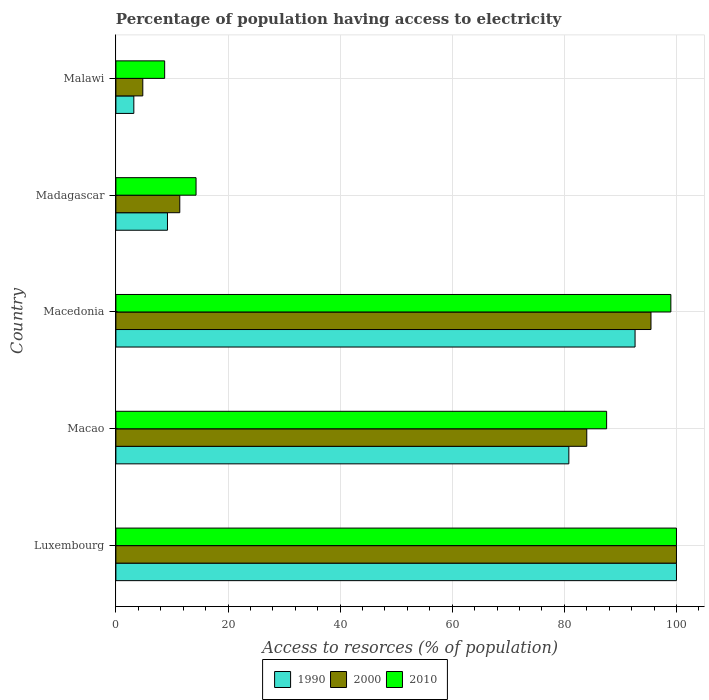How many different coloured bars are there?
Provide a short and direct response. 3. How many groups of bars are there?
Keep it short and to the point. 5. Are the number of bars per tick equal to the number of legend labels?
Keep it short and to the point. Yes. Are the number of bars on each tick of the Y-axis equal?
Your answer should be compact. Yes. How many bars are there on the 4th tick from the top?
Offer a terse response. 3. How many bars are there on the 3rd tick from the bottom?
Your answer should be compact. 3. What is the label of the 3rd group of bars from the top?
Ensure brevity in your answer.  Macedonia. In how many cases, is the number of bars for a given country not equal to the number of legend labels?
Your answer should be compact. 0. In which country was the percentage of population having access to electricity in 1990 maximum?
Keep it short and to the point. Luxembourg. In which country was the percentage of population having access to electricity in 2000 minimum?
Provide a short and direct response. Malawi. What is the total percentage of population having access to electricity in 2000 in the graph?
Offer a very short reply. 295.65. What is the difference between the percentage of population having access to electricity in 2010 in Macao and that in Macedonia?
Your answer should be compact. -11.46. What is the difference between the percentage of population having access to electricity in 2010 in Macao and the percentage of population having access to electricity in 1990 in Malawi?
Your response must be concise. 84.34. What is the average percentage of population having access to electricity in 2000 per country?
Make the answer very short. 59.13. What is the difference between the percentage of population having access to electricity in 2000 and percentage of population having access to electricity in 1990 in Malawi?
Your response must be concise. 1.6. In how many countries, is the percentage of population having access to electricity in 1990 greater than 80 %?
Your answer should be very brief. 3. What is the ratio of the percentage of population having access to electricity in 2010 in Luxembourg to that in Madagascar?
Offer a very short reply. 6.99. Is the percentage of population having access to electricity in 2000 in Macedonia less than that in Malawi?
Offer a terse response. No. Is the difference between the percentage of population having access to electricity in 2000 in Macao and Macedonia greater than the difference between the percentage of population having access to electricity in 1990 in Macao and Macedonia?
Give a very brief answer. Yes. What is the difference between the highest and the second highest percentage of population having access to electricity in 1990?
Provide a short and direct response. 7.38. What is the difference between the highest and the lowest percentage of population having access to electricity in 1990?
Give a very brief answer. 96.8. In how many countries, is the percentage of population having access to electricity in 2000 greater than the average percentage of population having access to electricity in 2000 taken over all countries?
Your response must be concise. 3. What does the 3rd bar from the bottom in Macedonia represents?
Keep it short and to the point. 2010. Is it the case that in every country, the sum of the percentage of population having access to electricity in 2010 and percentage of population having access to electricity in 2000 is greater than the percentage of population having access to electricity in 1990?
Make the answer very short. Yes. How many bars are there?
Make the answer very short. 15. Are all the bars in the graph horizontal?
Your answer should be very brief. Yes. How many countries are there in the graph?
Offer a terse response. 5. What is the difference between two consecutive major ticks on the X-axis?
Make the answer very short. 20. Does the graph contain any zero values?
Give a very brief answer. No. Does the graph contain grids?
Provide a short and direct response. Yes. Where does the legend appear in the graph?
Your answer should be compact. Bottom center. How many legend labels are there?
Keep it short and to the point. 3. How are the legend labels stacked?
Your answer should be compact. Horizontal. What is the title of the graph?
Offer a terse response. Percentage of population having access to electricity. Does "1964" appear as one of the legend labels in the graph?
Provide a short and direct response. No. What is the label or title of the X-axis?
Provide a short and direct response. Access to resorces (% of population). What is the Access to resorces (% of population) of 2000 in Luxembourg?
Offer a terse response. 100. What is the Access to resorces (% of population) of 1990 in Macao?
Your answer should be very brief. 80.8. What is the Access to resorces (% of population) in 2010 in Macao?
Offer a very short reply. 87.54. What is the Access to resorces (% of population) in 1990 in Macedonia?
Give a very brief answer. 92.62. What is the Access to resorces (% of population) in 2000 in Macedonia?
Offer a terse response. 95.46. What is the Access to resorces (% of population) of 1990 in Madagascar?
Your answer should be very brief. 9.2. What is the Access to resorces (% of population) in 2000 in Madagascar?
Give a very brief answer. 11.4. Across all countries, what is the maximum Access to resorces (% of population) in 1990?
Provide a succinct answer. 100. Across all countries, what is the maximum Access to resorces (% of population) in 2010?
Your answer should be very brief. 100. Across all countries, what is the minimum Access to resorces (% of population) in 2010?
Your answer should be compact. 8.7. What is the total Access to resorces (% of population) of 1990 in the graph?
Offer a very short reply. 285.82. What is the total Access to resorces (% of population) of 2000 in the graph?
Provide a short and direct response. 295.65. What is the total Access to resorces (% of population) in 2010 in the graph?
Give a very brief answer. 309.54. What is the difference between the Access to resorces (% of population) in 1990 in Luxembourg and that in Macao?
Make the answer very short. 19.2. What is the difference between the Access to resorces (% of population) of 2000 in Luxembourg and that in Macao?
Offer a very short reply. 16. What is the difference between the Access to resorces (% of population) in 2010 in Luxembourg and that in Macao?
Offer a very short reply. 12.46. What is the difference between the Access to resorces (% of population) of 1990 in Luxembourg and that in Macedonia?
Offer a terse response. 7.38. What is the difference between the Access to resorces (% of population) of 2000 in Luxembourg and that in Macedonia?
Your answer should be very brief. 4.54. What is the difference between the Access to resorces (% of population) in 1990 in Luxembourg and that in Madagascar?
Your response must be concise. 90.8. What is the difference between the Access to resorces (% of population) in 2000 in Luxembourg and that in Madagascar?
Provide a succinct answer. 88.6. What is the difference between the Access to resorces (% of population) in 2010 in Luxembourg and that in Madagascar?
Provide a succinct answer. 85.7. What is the difference between the Access to resorces (% of population) of 1990 in Luxembourg and that in Malawi?
Offer a terse response. 96.8. What is the difference between the Access to resorces (% of population) of 2000 in Luxembourg and that in Malawi?
Keep it short and to the point. 95.2. What is the difference between the Access to resorces (% of population) of 2010 in Luxembourg and that in Malawi?
Ensure brevity in your answer.  91.3. What is the difference between the Access to resorces (% of population) in 1990 in Macao and that in Macedonia?
Provide a short and direct response. -11.81. What is the difference between the Access to resorces (% of population) in 2000 in Macao and that in Macedonia?
Ensure brevity in your answer.  -11.46. What is the difference between the Access to resorces (% of population) in 2010 in Macao and that in Macedonia?
Make the answer very short. -11.46. What is the difference between the Access to resorces (% of population) in 1990 in Macao and that in Madagascar?
Provide a short and direct response. 71.6. What is the difference between the Access to resorces (% of population) in 2000 in Macao and that in Madagascar?
Keep it short and to the point. 72.6. What is the difference between the Access to resorces (% of population) in 2010 in Macao and that in Madagascar?
Ensure brevity in your answer.  73.24. What is the difference between the Access to resorces (% of population) in 1990 in Macao and that in Malawi?
Your response must be concise. 77.6. What is the difference between the Access to resorces (% of population) of 2000 in Macao and that in Malawi?
Keep it short and to the point. 79.2. What is the difference between the Access to resorces (% of population) of 2010 in Macao and that in Malawi?
Your answer should be compact. 78.84. What is the difference between the Access to resorces (% of population) of 1990 in Macedonia and that in Madagascar?
Ensure brevity in your answer.  83.42. What is the difference between the Access to resorces (% of population) in 2000 in Macedonia and that in Madagascar?
Your answer should be compact. 84.06. What is the difference between the Access to resorces (% of population) in 2010 in Macedonia and that in Madagascar?
Offer a terse response. 84.7. What is the difference between the Access to resorces (% of population) in 1990 in Macedonia and that in Malawi?
Provide a succinct answer. 89.42. What is the difference between the Access to resorces (% of population) in 2000 in Macedonia and that in Malawi?
Ensure brevity in your answer.  90.66. What is the difference between the Access to resorces (% of population) in 2010 in Macedonia and that in Malawi?
Make the answer very short. 90.3. What is the difference between the Access to resorces (% of population) in 2000 in Madagascar and that in Malawi?
Provide a succinct answer. 6.6. What is the difference between the Access to resorces (% of population) of 1990 in Luxembourg and the Access to resorces (% of population) of 2010 in Macao?
Your answer should be compact. 12.46. What is the difference between the Access to resorces (% of population) of 2000 in Luxembourg and the Access to resorces (% of population) of 2010 in Macao?
Your answer should be very brief. 12.46. What is the difference between the Access to resorces (% of population) in 1990 in Luxembourg and the Access to resorces (% of population) in 2000 in Macedonia?
Make the answer very short. 4.54. What is the difference between the Access to resorces (% of population) of 1990 in Luxembourg and the Access to resorces (% of population) of 2010 in Macedonia?
Your response must be concise. 1. What is the difference between the Access to resorces (% of population) in 1990 in Luxembourg and the Access to resorces (% of population) in 2000 in Madagascar?
Give a very brief answer. 88.6. What is the difference between the Access to resorces (% of population) in 1990 in Luxembourg and the Access to resorces (% of population) in 2010 in Madagascar?
Offer a very short reply. 85.7. What is the difference between the Access to resorces (% of population) of 2000 in Luxembourg and the Access to resorces (% of population) of 2010 in Madagascar?
Make the answer very short. 85.7. What is the difference between the Access to resorces (% of population) in 1990 in Luxembourg and the Access to resorces (% of population) in 2000 in Malawi?
Your answer should be compact. 95.2. What is the difference between the Access to resorces (% of population) of 1990 in Luxembourg and the Access to resorces (% of population) of 2010 in Malawi?
Provide a succinct answer. 91.3. What is the difference between the Access to resorces (% of population) in 2000 in Luxembourg and the Access to resorces (% of population) in 2010 in Malawi?
Provide a short and direct response. 91.3. What is the difference between the Access to resorces (% of population) in 1990 in Macao and the Access to resorces (% of population) in 2000 in Macedonia?
Offer a terse response. -14.65. What is the difference between the Access to resorces (% of population) in 1990 in Macao and the Access to resorces (% of population) in 2010 in Macedonia?
Give a very brief answer. -18.2. What is the difference between the Access to resorces (% of population) of 2000 in Macao and the Access to resorces (% of population) of 2010 in Macedonia?
Make the answer very short. -15. What is the difference between the Access to resorces (% of population) of 1990 in Macao and the Access to resorces (% of population) of 2000 in Madagascar?
Make the answer very short. 69.4. What is the difference between the Access to resorces (% of population) of 1990 in Macao and the Access to resorces (% of population) of 2010 in Madagascar?
Offer a very short reply. 66.5. What is the difference between the Access to resorces (% of population) in 2000 in Macao and the Access to resorces (% of population) in 2010 in Madagascar?
Ensure brevity in your answer.  69.7. What is the difference between the Access to resorces (% of population) of 1990 in Macao and the Access to resorces (% of population) of 2000 in Malawi?
Give a very brief answer. 76. What is the difference between the Access to resorces (% of population) in 1990 in Macao and the Access to resorces (% of population) in 2010 in Malawi?
Keep it short and to the point. 72.1. What is the difference between the Access to resorces (% of population) in 2000 in Macao and the Access to resorces (% of population) in 2010 in Malawi?
Ensure brevity in your answer.  75.3. What is the difference between the Access to resorces (% of population) in 1990 in Macedonia and the Access to resorces (% of population) in 2000 in Madagascar?
Your answer should be very brief. 81.22. What is the difference between the Access to resorces (% of population) in 1990 in Macedonia and the Access to resorces (% of population) in 2010 in Madagascar?
Make the answer very short. 78.32. What is the difference between the Access to resorces (% of population) in 2000 in Macedonia and the Access to resorces (% of population) in 2010 in Madagascar?
Provide a succinct answer. 81.16. What is the difference between the Access to resorces (% of population) of 1990 in Macedonia and the Access to resorces (% of population) of 2000 in Malawi?
Provide a succinct answer. 87.82. What is the difference between the Access to resorces (% of population) of 1990 in Macedonia and the Access to resorces (% of population) of 2010 in Malawi?
Offer a terse response. 83.92. What is the difference between the Access to resorces (% of population) in 2000 in Macedonia and the Access to resorces (% of population) in 2010 in Malawi?
Provide a succinct answer. 86.76. What is the difference between the Access to resorces (% of population) of 1990 in Madagascar and the Access to resorces (% of population) of 2000 in Malawi?
Your response must be concise. 4.4. What is the difference between the Access to resorces (% of population) in 1990 in Madagascar and the Access to resorces (% of population) in 2010 in Malawi?
Your answer should be very brief. 0.5. What is the difference between the Access to resorces (% of population) of 2000 in Madagascar and the Access to resorces (% of population) of 2010 in Malawi?
Make the answer very short. 2.7. What is the average Access to resorces (% of population) of 1990 per country?
Your response must be concise. 57.16. What is the average Access to resorces (% of population) of 2000 per country?
Your response must be concise. 59.13. What is the average Access to resorces (% of population) in 2010 per country?
Give a very brief answer. 61.91. What is the difference between the Access to resorces (% of population) of 1990 and Access to resorces (% of population) of 2010 in Luxembourg?
Offer a very short reply. 0. What is the difference between the Access to resorces (% of population) of 2000 and Access to resorces (% of population) of 2010 in Luxembourg?
Offer a very short reply. 0. What is the difference between the Access to resorces (% of population) of 1990 and Access to resorces (% of population) of 2000 in Macao?
Ensure brevity in your answer.  -3.2. What is the difference between the Access to resorces (% of population) in 1990 and Access to resorces (% of population) in 2010 in Macao?
Your response must be concise. -6.74. What is the difference between the Access to resorces (% of population) in 2000 and Access to resorces (% of population) in 2010 in Macao?
Your answer should be very brief. -3.54. What is the difference between the Access to resorces (% of population) in 1990 and Access to resorces (% of population) in 2000 in Macedonia?
Your answer should be compact. -2.84. What is the difference between the Access to resorces (% of population) in 1990 and Access to resorces (% of population) in 2010 in Macedonia?
Provide a short and direct response. -6.38. What is the difference between the Access to resorces (% of population) in 2000 and Access to resorces (% of population) in 2010 in Macedonia?
Ensure brevity in your answer.  -3.54. What is the difference between the Access to resorces (% of population) of 1990 and Access to resorces (% of population) of 2000 in Madagascar?
Your response must be concise. -2.2. What is the difference between the Access to resorces (% of population) in 1990 and Access to resorces (% of population) in 2010 in Madagascar?
Give a very brief answer. -5.1. What is the difference between the Access to resorces (% of population) of 2000 and Access to resorces (% of population) of 2010 in Madagascar?
Your response must be concise. -2.9. What is the difference between the Access to resorces (% of population) of 1990 and Access to resorces (% of population) of 2010 in Malawi?
Your response must be concise. -5.5. What is the difference between the Access to resorces (% of population) of 2000 and Access to resorces (% of population) of 2010 in Malawi?
Your answer should be very brief. -3.9. What is the ratio of the Access to resorces (% of population) of 1990 in Luxembourg to that in Macao?
Ensure brevity in your answer.  1.24. What is the ratio of the Access to resorces (% of population) of 2000 in Luxembourg to that in Macao?
Ensure brevity in your answer.  1.19. What is the ratio of the Access to resorces (% of population) of 2010 in Luxembourg to that in Macao?
Offer a terse response. 1.14. What is the ratio of the Access to resorces (% of population) in 1990 in Luxembourg to that in Macedonia?
Your response must be concise. 1.08. What is the ratio of the Access to resorces (% of population) of 2000 in Luxembourg to that in Macedonia?
Your response must be concise. 1.05. What is the ratio of the Access to resorces (% of population) in 2010 in Luxembourg to that in Macedonia?
Your answer should be compact. 1.01. What is the ratio of the Access to resorces (% of population) of 1990 in Luxembourg to that in Madagascar?
Your answer should be very brief. 10.87. What is the ratio of the Access to resorces (% of population) in 2000 in Luxembourg to that in Madagascar?
Your response must be concise. 8.77. What is the ratio of the Access to resorces (% of population) of 2010 in Luxembourg to that in Madagascar?
Provide a succinct answer. 6.99. What is the ratio of the Access to resorces (% of population) of 1990 in Luxembourg to that in Malawi?
Offer a terse response. 31.25. What is the ratio of the Access to resorces (% of population) of 2000 in Luxembourg to that in Malawi?
Provide a succinct answer. 20.83. What is the ratio of the Access to resorces (% of population) of 2010 in Luxembourg to that in Malawi?
Your response must be concise. 11.49. What is the ratio of the Access to resorces (% of population) in 1990 in Macao to that in Macedonia?
Offer a very short reply. 0.87. What is the ratio of the Access to resorces (% of population) of 2000 in Macao to that in Macedonia?
Offer a terse response. 0.88. What is the ratio of the Access to resorces (% of population) in 2010 in Macao to that in Macedonia?
Keep it short and to the point. 0.88. What is the ratio of the Access to resorces (% of population) in 1990 in Macao to that in Madagascar?
Keep it short and to the point. 8.78. What is the ratio of the Access to resorces (% of population) in 2000 in Macao to that in Madagascar?
Give a very brief answer. 7.37. What is the ratio of the Access to resorces (% of population) in 2010 in Macao to that in Madagascar?
Keep it short and to the point. 6.12. What is the ratio of the Access to resorces (% of population) in 1990 in Macao to that in Malawi?
Offer a terse response. 25.25. What is the ratio of the Access to resorces (% of population) of 2010 in Macao to that in Malawi?
Offer a very short reply. 10.06. What is the ratio of the Access to resorces (% of population) of 1990 in Macedonia to that in Madagascar?
Make the answer very short. 10.07. What is the ratio of the Access to resorces (% of population) in 2000 in Macedonia to that in Madagascar?
Offer a very short reply. 8.37. What is the ratio of the Access to resorces (% of population) in 2010 in Macedonia to that in Madagascar?
Keep it short and to the point. 6.92. What is the ratio of the Access to resorces (% of population) in 1990 in Macedonia to that in Malawi?
Provide a succinct answer. 28.94. What is the ratio of the Access to resorces (% of population) in 2000 in Macedonia to that in Malawi?
Keep it short and to the point. 19.89. What is the ratio of the Access to resorces (% of population) in 2010 in Macedonia to that in Malawi?
Ensure brevity in your answer.  11.38. What is the ratio of the Access to resorces (% of population) in 1990 in Madagascar to that in Malawi?
Offer a very short reply. 2.88. What is the ratio of the Access to resorces (% of population) of 2000 in Madagascar to that in Malawi?
Keep it short and to the point. 2.37. What is the ratio of the Access to resorces (% of population) in 2010 in Madagascar to that in Malawi?
Give a very brief answer. 1.64. What is the difference between the highest and the second highest Access to resorces (% of population) in 1990?
Give a very brief answer. 7.38. What is the difference between the highest and the second highest Access to resorces (% of population) in 2000?
Your answer should be compact. 4.54. What is the difference between the highest and the lowest Access to resorces (% of population) in 1990?
Your answer should be compact. 96.8. What is the difference between the highest and the lowest Access to resorces (% of population) in 2000?
Your answer should be compact. 95.2. What is the difference between the highest and the lowest Access to resorces (% of population) in 2010?
Ensure brevity in your answer.  91.3. 